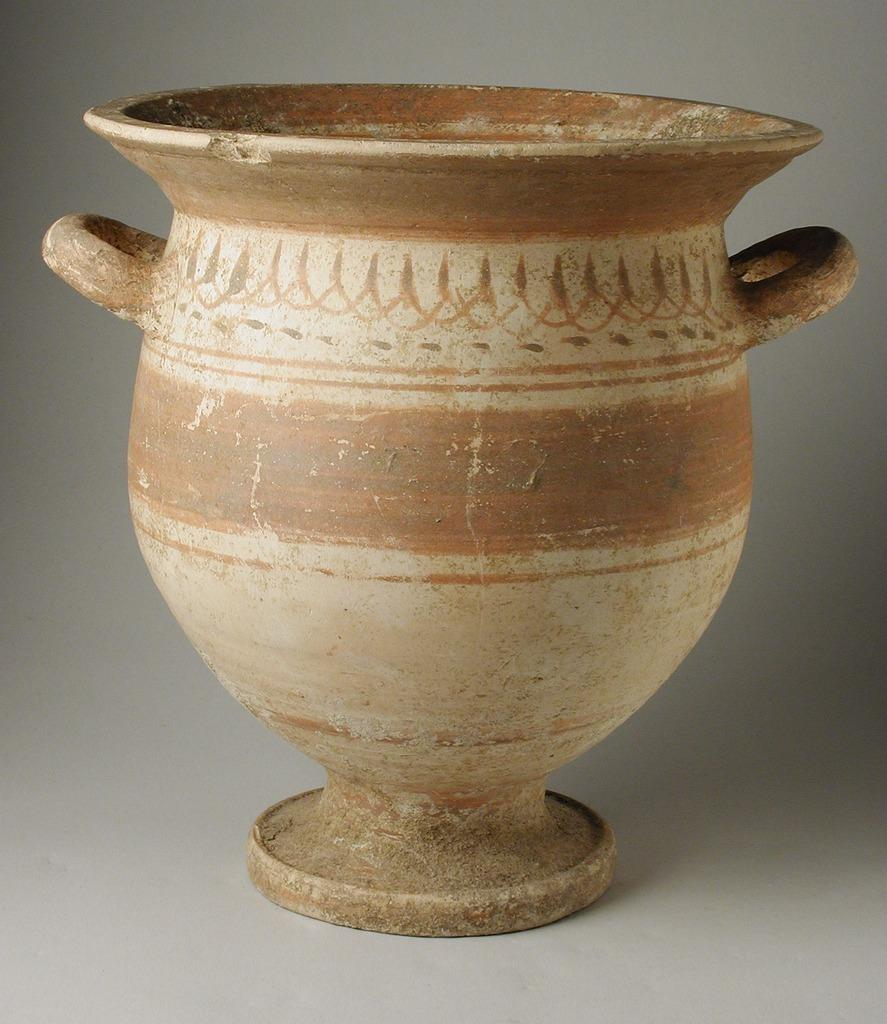What is the main subject in the image? There is an object in the image. Can you describe the surface on which the object is placed? The object is placed on a white surface. What type of thrill can be experienced by the camera in the image? There is no camera present in the image, and therefore no such experience can be observed. 